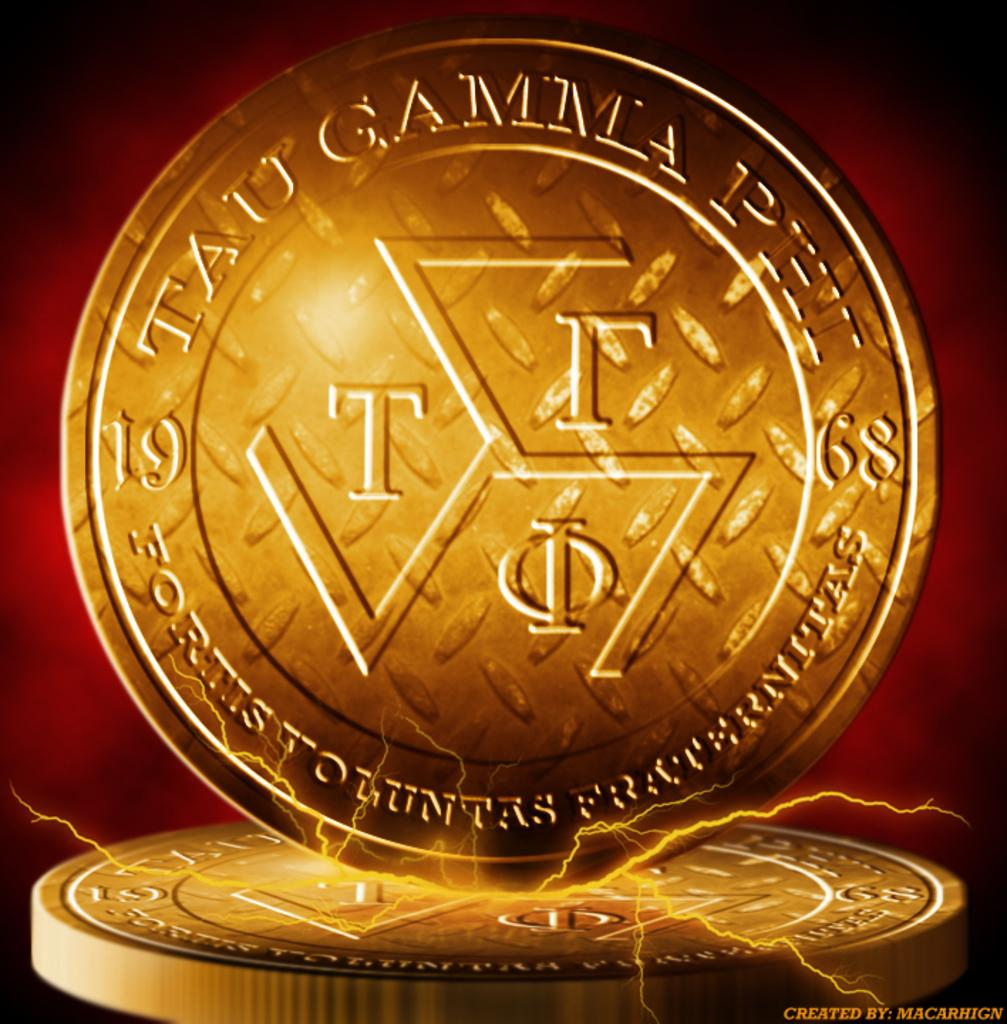What is located in the center of the image? There are coins in the center of the image. What type of wound can be seen on the sand in the image? There is no sand or wound present in the image; it only features coins in the center. 